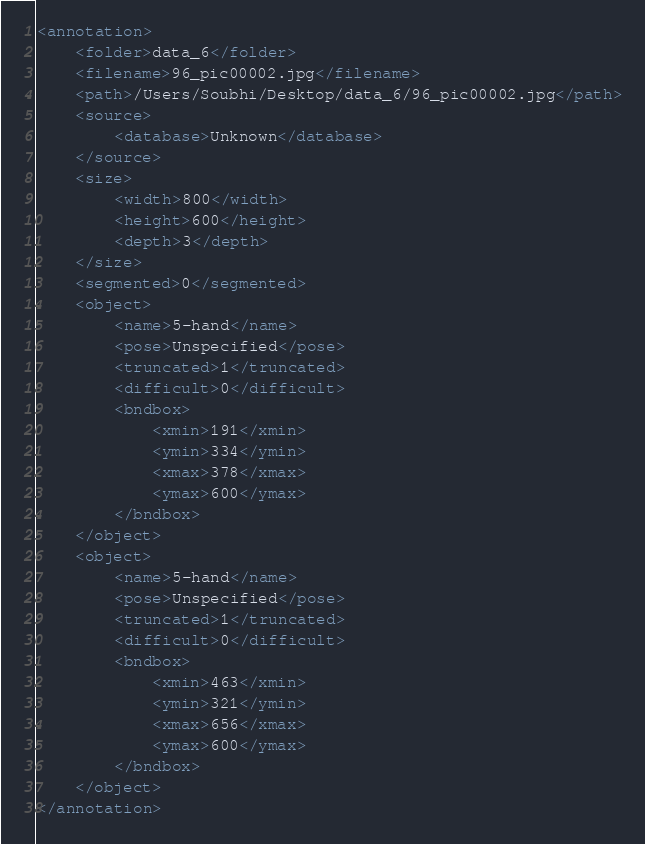Convert code to text. <code><loc_0><loc_0><loc_500><loc_500><_XML_><annotation>
	<folder>data_6</folder>
	<filename>96_pic00002.jpg</filename>
	<path>/Users/Soubhi/Desktop/data_6/96_pic00002.jpg</path>
	<source>
		<database>Unknown</database>
	</source>
	<size>
		<width>800</width>
		<height>600</height>
		<depth>3</depth>
	</size>
	<segmented>0</segmented>
	<object>
		<name>5-hand</name>
		<pose>Unspecified</pose>
		<truncated>1</truncated>
		<difficult>0</difficult>
		<bndbox>
			<xmin>191</xmin>
			<ymin>334</ymin>
			<xmax>378</xmax>
			<ymax>600</ymax>
		</bndbox>
	</object>
	<object>
		<name>5-hand</name>
		<pose>Unspecified</pose>
		<truncated>1</truncated>
		<difficult>0</difficult>
		<bndbox>
			<xmin>463</xmin>
			<ymin>321</ymin>
			<xmax>656</xmax>
			<ymax>600</ymax>
		</bndbox>
	</object>
</annotation>
</code> 